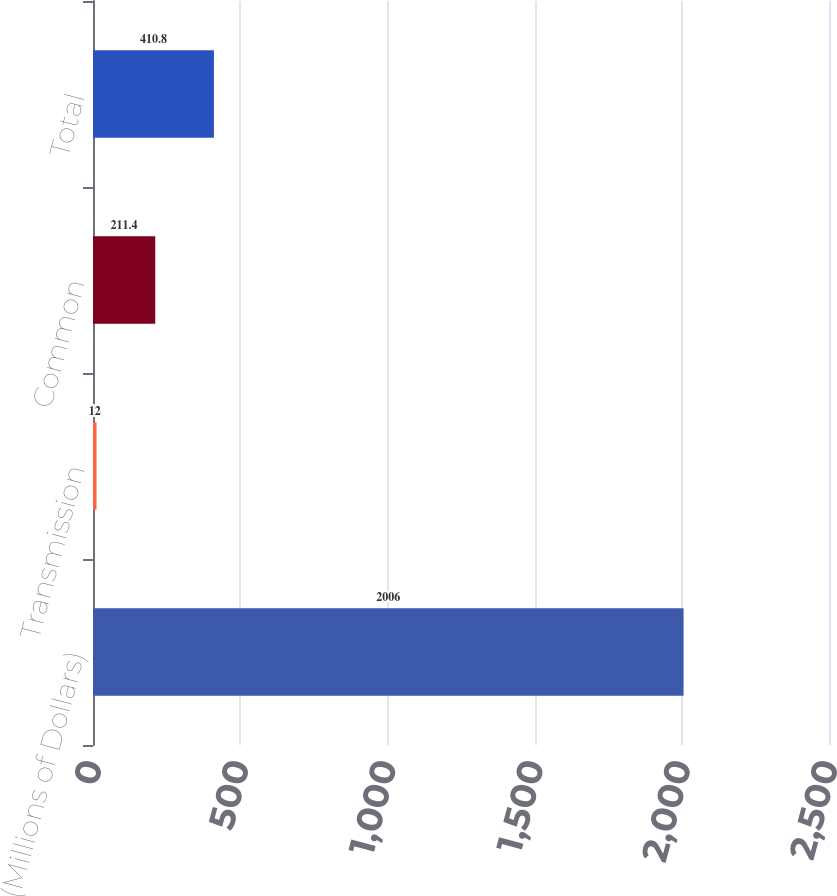<chart> <loc_0><loc_0><loc_500><loc_500><bar_chart><fcel>(Millions of Dollars)<fcel>Transmission<fcel>Common<fcel>Total<nl><fcel>2006<fcel>12<fcel>211.4<fcel>410.8<nl></chart> 